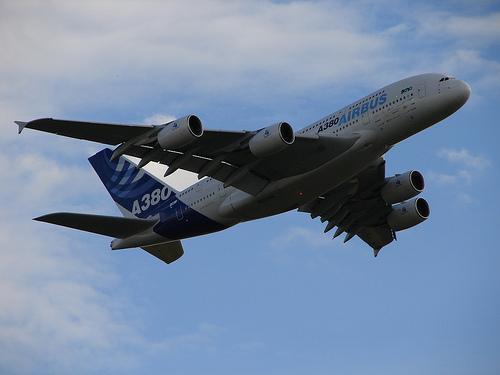How many wings are there?
Give a very brief answer. 2. 